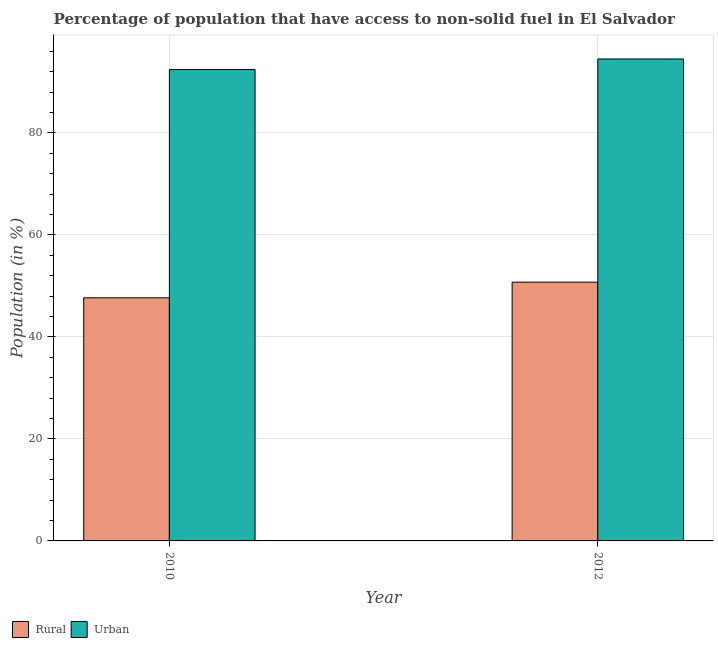How many different coloured bars are there?
Provide a short and direct response. 2. How many groups of bars are there?
Your answer should be very brief. 2. What is the label of the 2nd group of bars from the left?
Your response must be concise. 2012. In how many cases, is the number of bars for a given year not equal to the number of legend labels?
Give a very brief answer. 0. What is the rural population in 2012?
Your response must be concise. 50.73. Across all years, what is the maximum urban population?
Give a very brief answer. 94.49. Across all years, what is the minimum rural population?
Your response must be concise. 47.66. In which year was the urban population maximum?
Offer a very short reply. 2012. In which year was the urban population minimum?
Offer a very short reply. 2010. What is the total rural population in the graph?
Offer a very short reply. 98.39. What is the difference between the rural population in 2010 and that in 2012?
Offer a very short reply. -3.07. What is the difference between the rural population in 2012 and the urban population in 2010?
Offer a terse response. 3.07. What is the average urban population per year?
Keep it short and to the point. 93.45. In how many years, is the urban population greater than 56 %?
Make the answer very short. 2. What is the ratio of the urban population in 2010 to that in 2012?
Offer a very short reply. 0.98. Is the urban population in 2010 less than that in 2012?
Your answer should be very brief. Yes. What does the 1st bar from the left in 2010 represents?
Your answer should be very brief. Rural. What does the 1st bar from the right in 2010 represents?
Provide a succinct answer. Urban. How many bars are there?
Ensure brevity in your answer.  4. Are all the bars in the graph horizontal?
Give a very brief answer. No. How many years are there in the graph?
Provide a succinct answer. 2. Are the values on the major ticks of Y-axis written in scientific E-notation?
Provide a short and direct response. No. Does the graph contain grids?
Offer a very short reply. Yes. Where does the legend appear in the graph?
Provide a short and direct response. Bottom left. How many legend labels are there?
Your answer should be very brief. 2. What is the title of the graph?
Offer a very short reply. Percentage of population that have access to non-solid fuel in El Salvador. Does "National Tourists" appear as one of the legend labels in the graph?
Give a very brief answer. No. What is the label or title of the Y-axis?
Your answer should be very brief. Population (in %). What is the Population (in %) of Rural in 2010?
Offer a terse response. 47.66. What is the Population (in %) in Urban in 2010?
Give a very brief answer. 92.41. What is the Population (in %) of Rural in 2012?
Provide a succinct answer. 50.73. What is the Population (in %) of Urban in 2012?
Keep it short and to the point. 94.49. Across all years, what is the maximum Population (in %) of Rural?
Your response must be concise. 50.73. Across all years, what is the maximum Population (in %) of Urban?
Make the answer very short. 94.49. Across all years, what is the minimum Population (in %) in Rural?
Offer a very short reply. 47.66. Across all years, what is the minimum Population (in %) in Urban?
Provide a succinct answer. 92.41. What is the total Population (in %) of Rural in the graph?
Ensure brevity in your answer.  98.39. What is the total Population (in %) of Urban in the graph?
Give a very brief answer. 186.9. What is the difference between the Population (in %) in Rural in 2010 and that in 2012?
Keep it short and to the point. -3.07. What is the difference between the Population (in %) in Urban in 2010 and that in 2012?
Offer a very short reply. -2.07. What is the difference between the Population (in %) of Rural in 2010 and the Population (in %) of Urban in 2012?
Provide a succinct answer. -46.82. What is the average Population (in %) of Rural per year?
Make the answer very short. 49.2. What is the average Population (in %) in Urban per year?
Provide a short and direct response. 93.45. In the year 2010, what is the difference between the Population (in %) in Rural and Population (in %) in Urban?
Ensure brevity in your answer.  -44.75. In the year 2012, what is the difference between the Population (in %) of Rural and Population (in %) of Urban?
Your answer should be very brief. -43.76. What is the ratio of the Population (in %) of Rural in 2010 to that in 2012?
Provide a short and direct response. 0.94. What is the ratio of the Population (in %) of Urban in 2010 to that in 2012?
Your response must be concise. 0.98. What is the difference between the highest and the second highest Population (in %) of Rural?
Provide a short and direct response. 3.07. What is the difference between the highest and the second highest Population (in %) of Urban?
Provide a short and direct response. 2.07. What is the difference between the highest and the lowest Population (in %) in Rural?
Keep it short and to the point. 3.07. What is the difference between the highest and the lowest Population (in %) of Urban?
Offer a terse response. 2.07. 